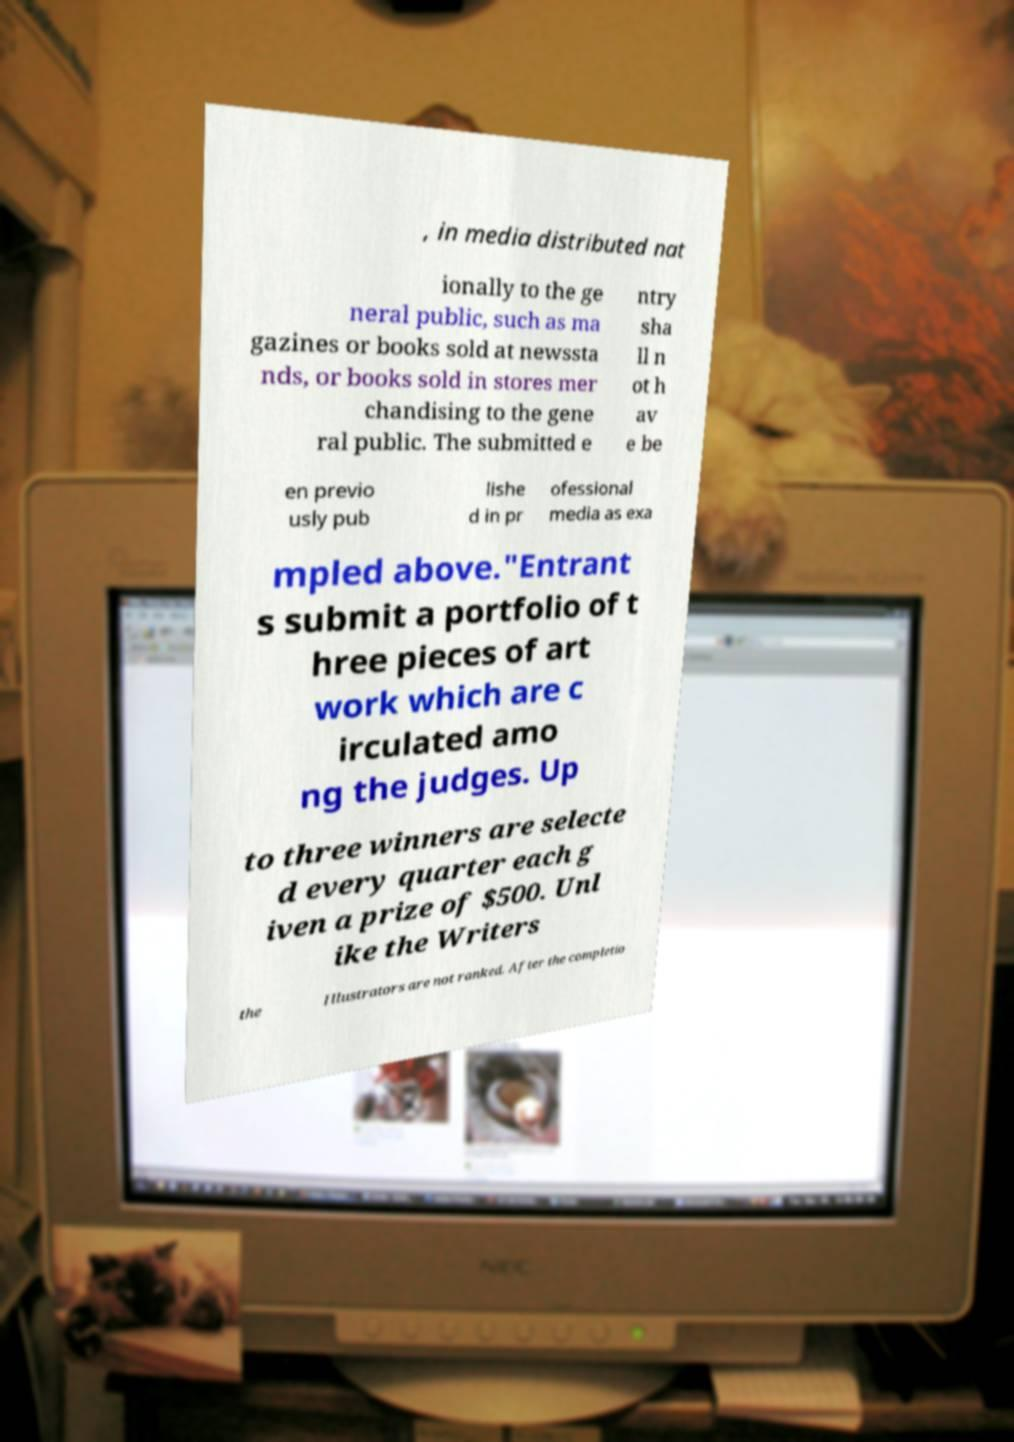Can you accurately transcribe the text from the provided image for me? , in media distributed nat ionally to the ge neral public, such as ma gazines or books sold at newssta nds, or books sold in stores mer chandising to the gene ral public. The submitted e ntry sha ll n ot h av e be en previo usly pub lishe d in pr ofessional media as exa mpled above."Entrant s submit a portfolio of t hree pieces of art work which are c irculated amo ng the judges. Up to three winners are selecte d every quarter each g iven a prize of $500. Unl ike the Writers the Illustrators are not ranked. After the completio 